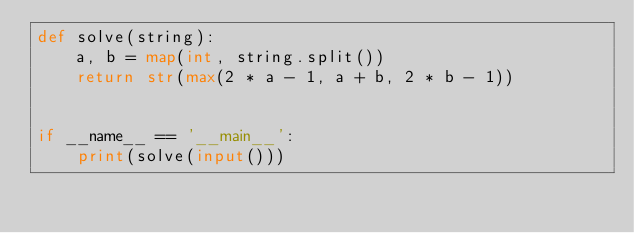<code> <loc_0><loc_0><loc_500><loc_500><_Python_>def solve(string):
    a, b = map(int, string.split())
    return str(max(2 * a - 1, a + b, 2 * b - 1))


if __name__ == '__main__':
    print(solve(input()))
</code> 